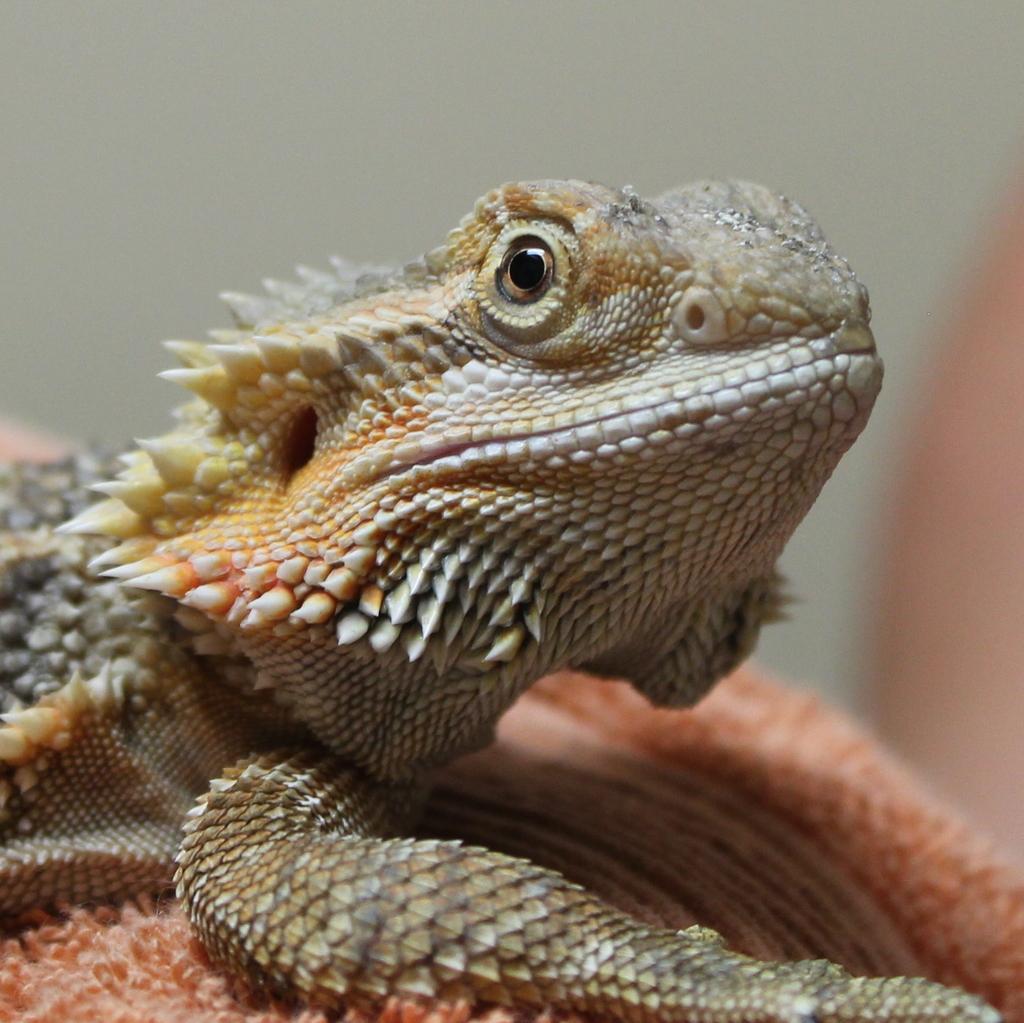Could you give a brief overview of what you see in this image? In this image we can see a reptile on the pink colored object and the background is blurred. 